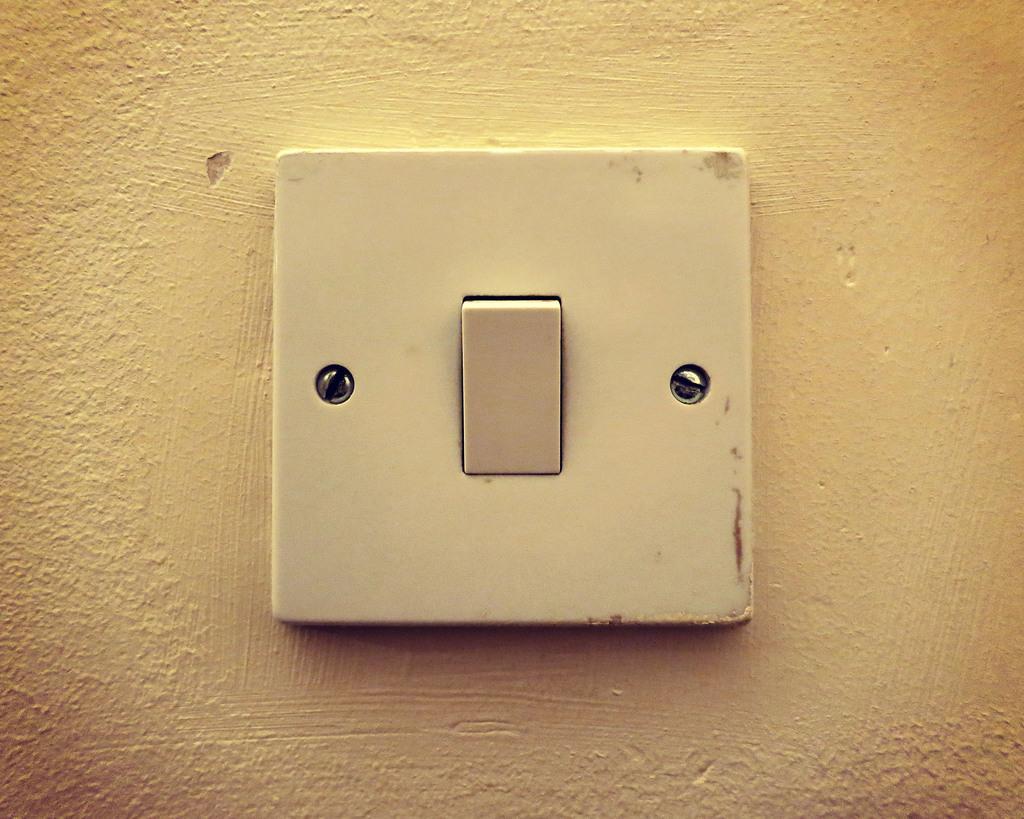How would you summarize this image in a sentence or two? In this image we can see a switch board fixed to a wall. 